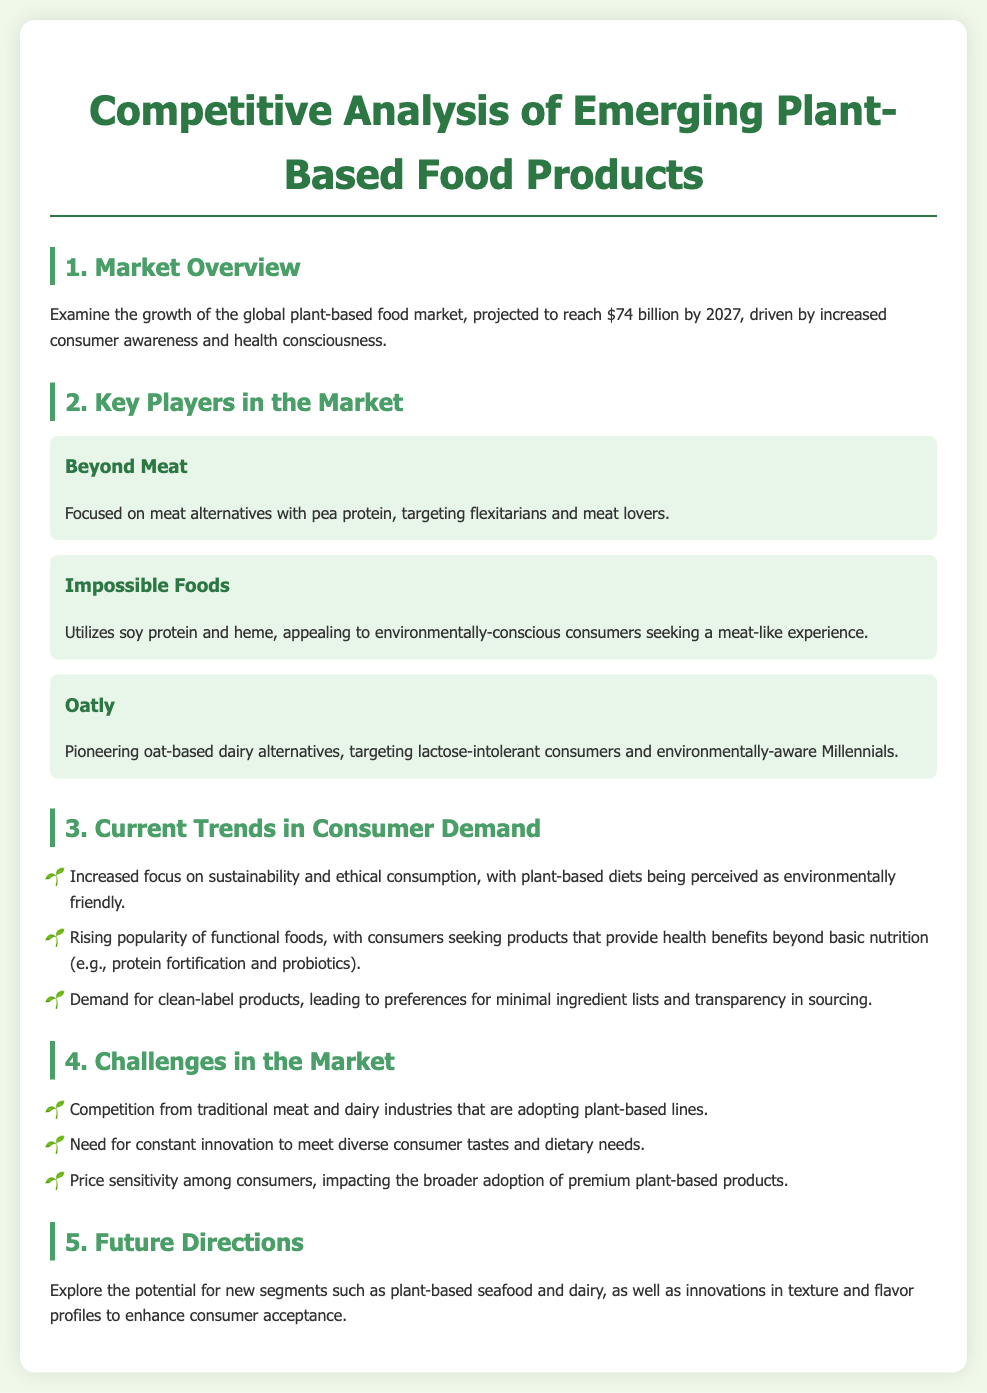What is the projected market value of the global plant-based food market by 2027? The document states that the global plant-based food market is projected to reach $74 billion by 2027.
Answer: $74 billion Which company focuses on meat alternatives with pea protein? Beyond Meat is the company focused on meat alternatives with pea protein, as mentioned in the key players section.
Answer: Beyond Meat What type of protein does Impossible Foods use? The document highlights that Impossible Foods utilizes soy protein and heme.
Answer: Soy protein and heme What sustainability trend is mentioned in the document? The document notes an increased focus on sustainability and ethical consumption, with plant-based diets perceived as environmentally friendly.
Answer: Sustainability and ethical consumption What challenges do plant-based products face in the market? The document lists several challenges, including competition from traditional meat and dairy industries and the need for constant innovation.
Answer: Competition and need for constant innovation Which consumer demographic does Oatly primarily target? Oatly targets lactose-intolerant consumers and environmentally-aware Millennials, as stated in the key players section.
Answer: Lactose-intolerant consumers and environmentally-aware Millennials What is one trend in consumer demand for plant-based products? The document outlines rising popularity of functional foods, indicating that consumers seek products with health benefits beyond basic nutrition.
Answer: Rising popularity of functional foods What innovation area is mentioned for enhancing consumer acceptance? The document suggests exploring innovations in texture and flavor profiles as a potential future direction.
Answer: Innovations in texture and flavor profiles 